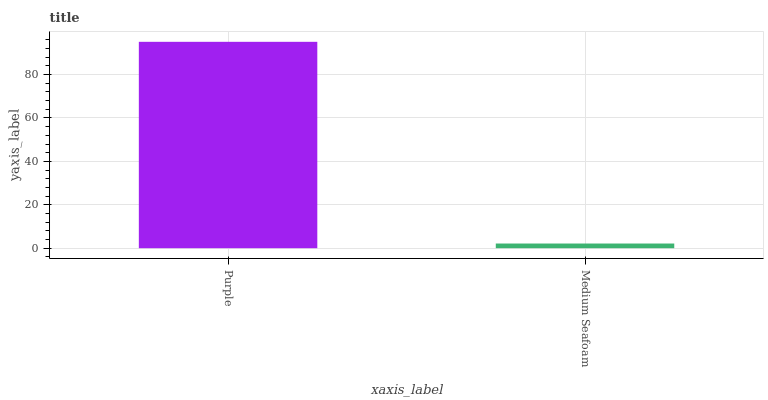Is Medium Seafoam the maximum?
Answer yes or no. No. Is Purple greater than Medium Seafoam?
Answer yes or no. Yes. Is Medium Seafoam less than Purple?
Answer yes or no. Yes. Is Medium Seafoam greater than Purple?
Answer yes or no. No. Is Purple less than Medium Seafoam?
Answer yes or no. No. Is Purple the high median?
Answer yes or no. Yes. Is Medium Seafoam the low median?
Answer yes or no. Yes. Is Medium Seafoam the high median?
Answer yes or no. No. Is Purple the low median?
Answer yes or no. No. 